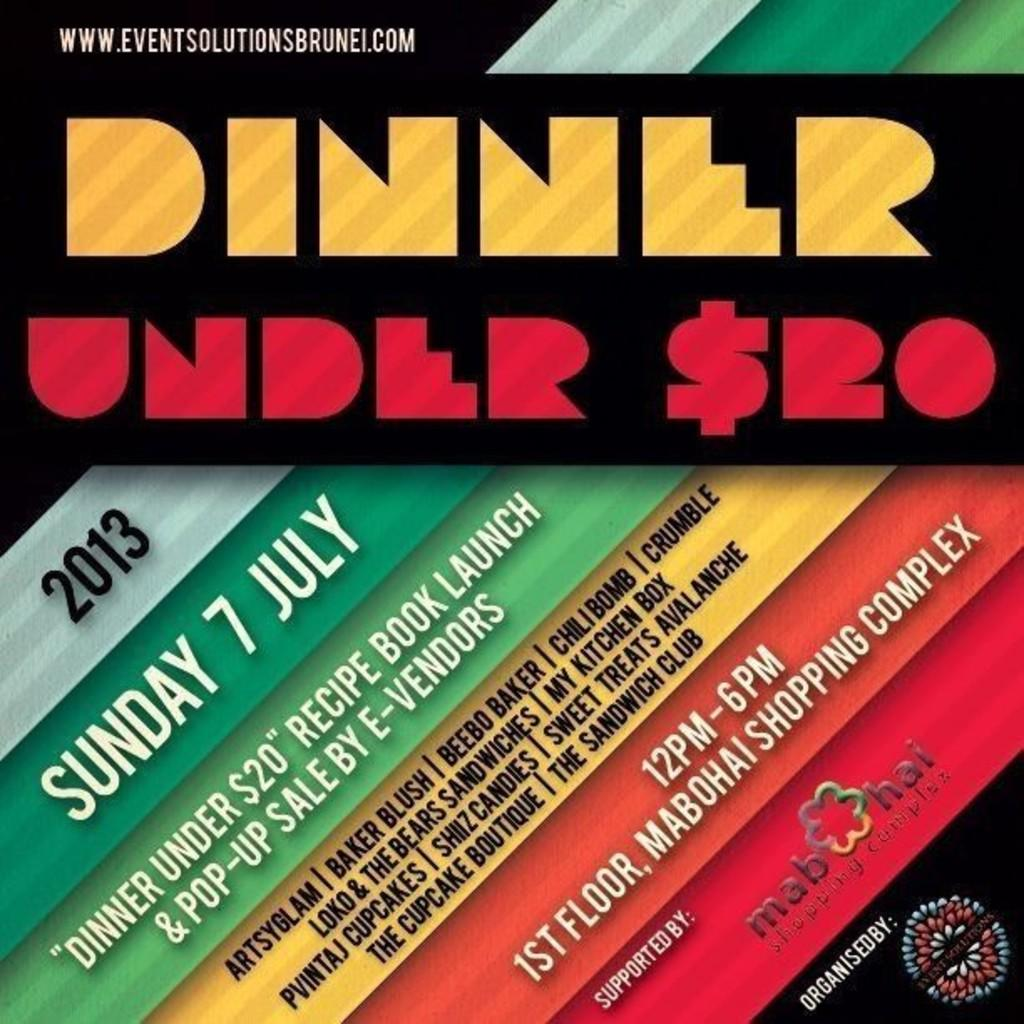<image>
Summarize the visual content of the image. The year being shown to the left is 2013. 